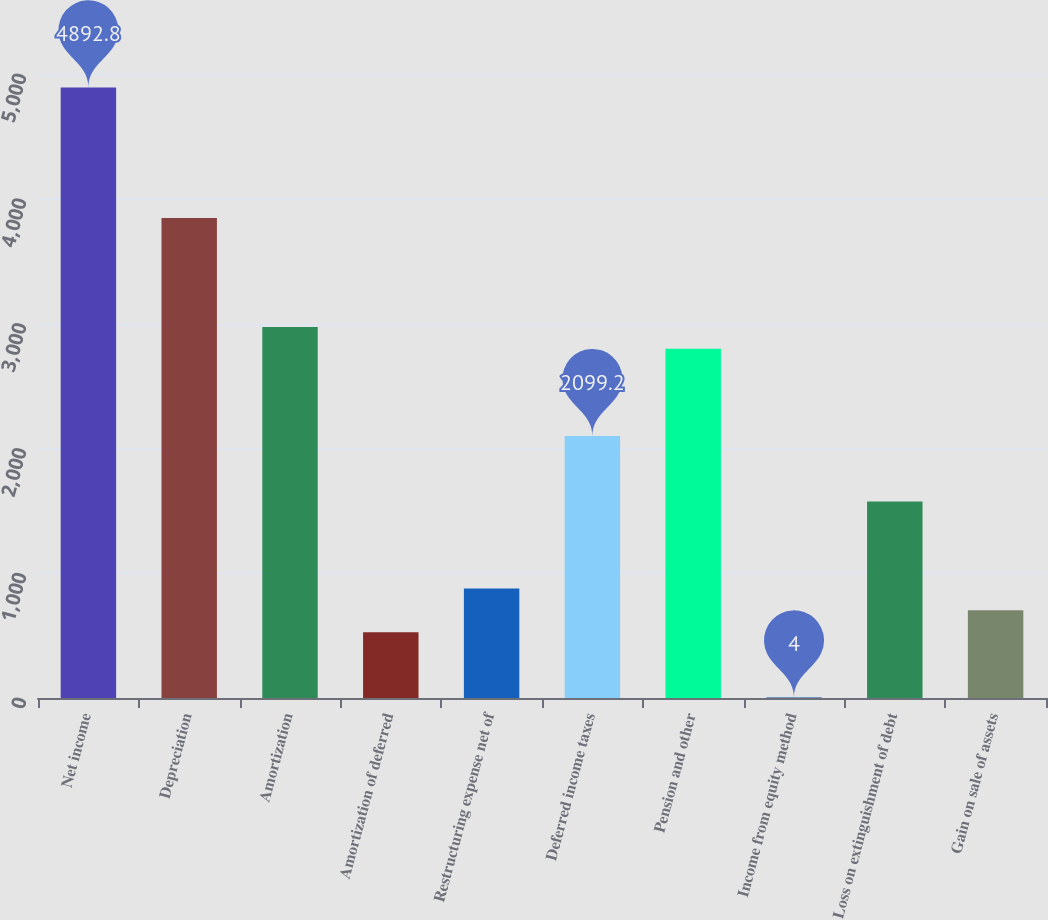<chart> <loc_0><loc_0><loc_500><loc_500><bar_chart><fcel>Net income<fcel>Depreciation<fcel>Amortization<fcel>Amortization of deferred<fcel>Restructuring expense net of<fcel>Deferred income taxes<fcel>Pension and other<fcel>Income from equity method<fcel>Loss on extinguishment of debt<fcel>Gain on sale of assets<nl><fcel>4892.8<fcel>3845.2<fcel>2972.2<fcel>527.8<fcel>877<fcel>2099.2<fcel>2797.6<fcel>4<fcel>1575.4<fcel>702.4<nl></chart> 